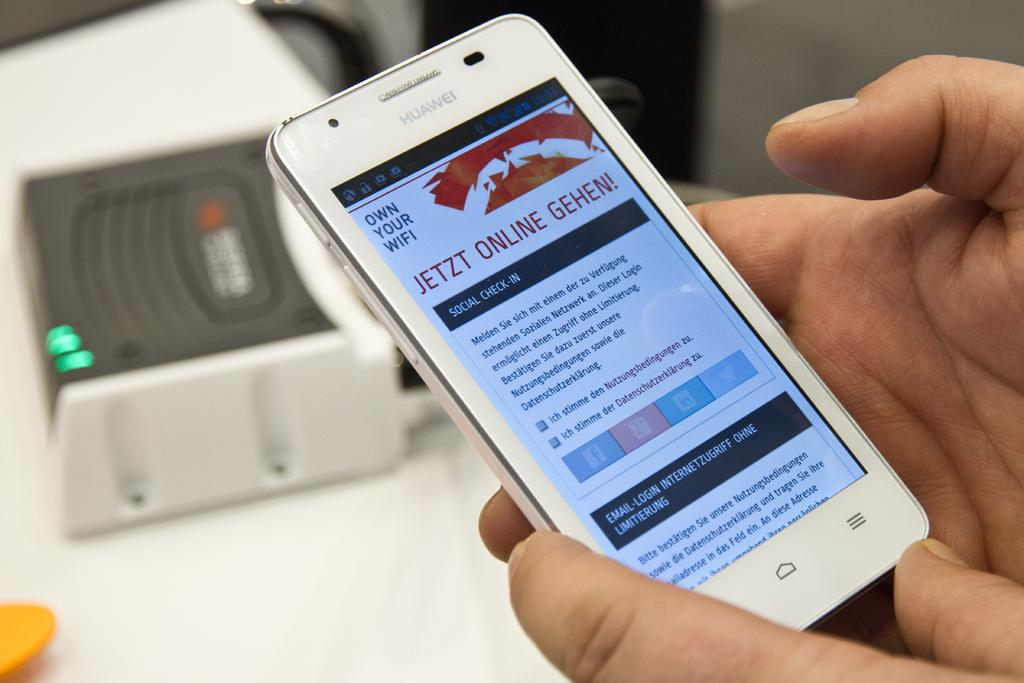<image>
Write a terse but informative summary of the picture. A silver Huawei branded cell phone being held in a person's hand. 